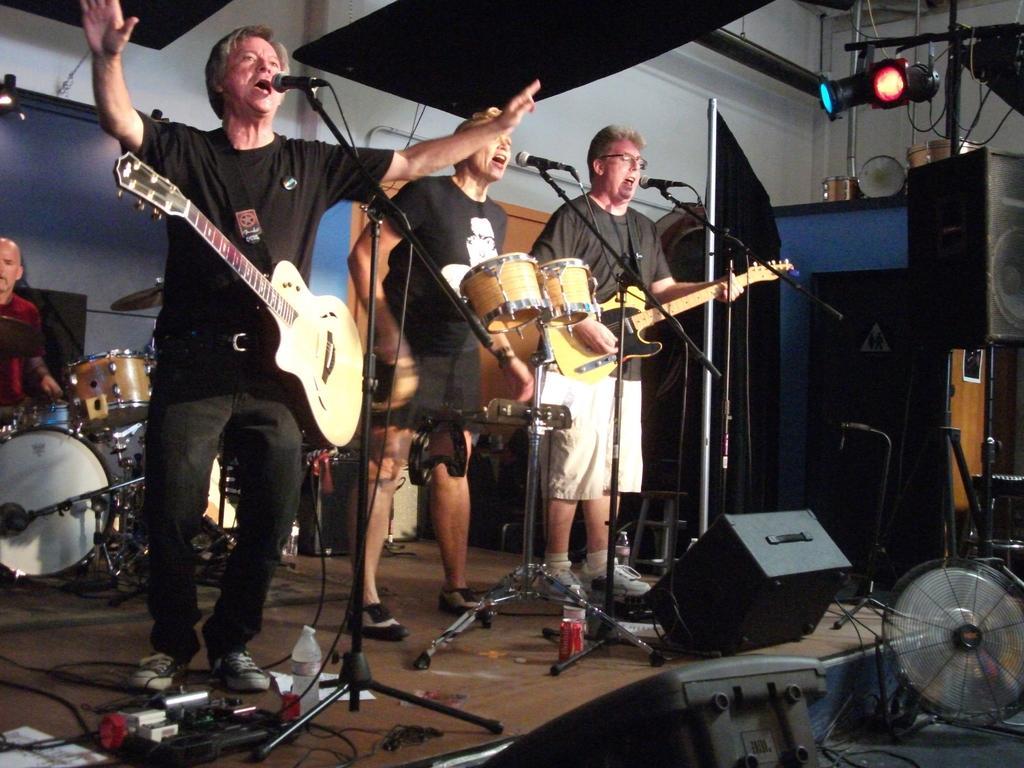Please provide a concise description of this image. On the background we can see wall. At the top these are lights. Here we can see persons standing in front of a mike singing and playing guitars and musical instruments on the platform. Behind to them we can see a man playing drums. On the platform we can see bottles, device, adapters. 